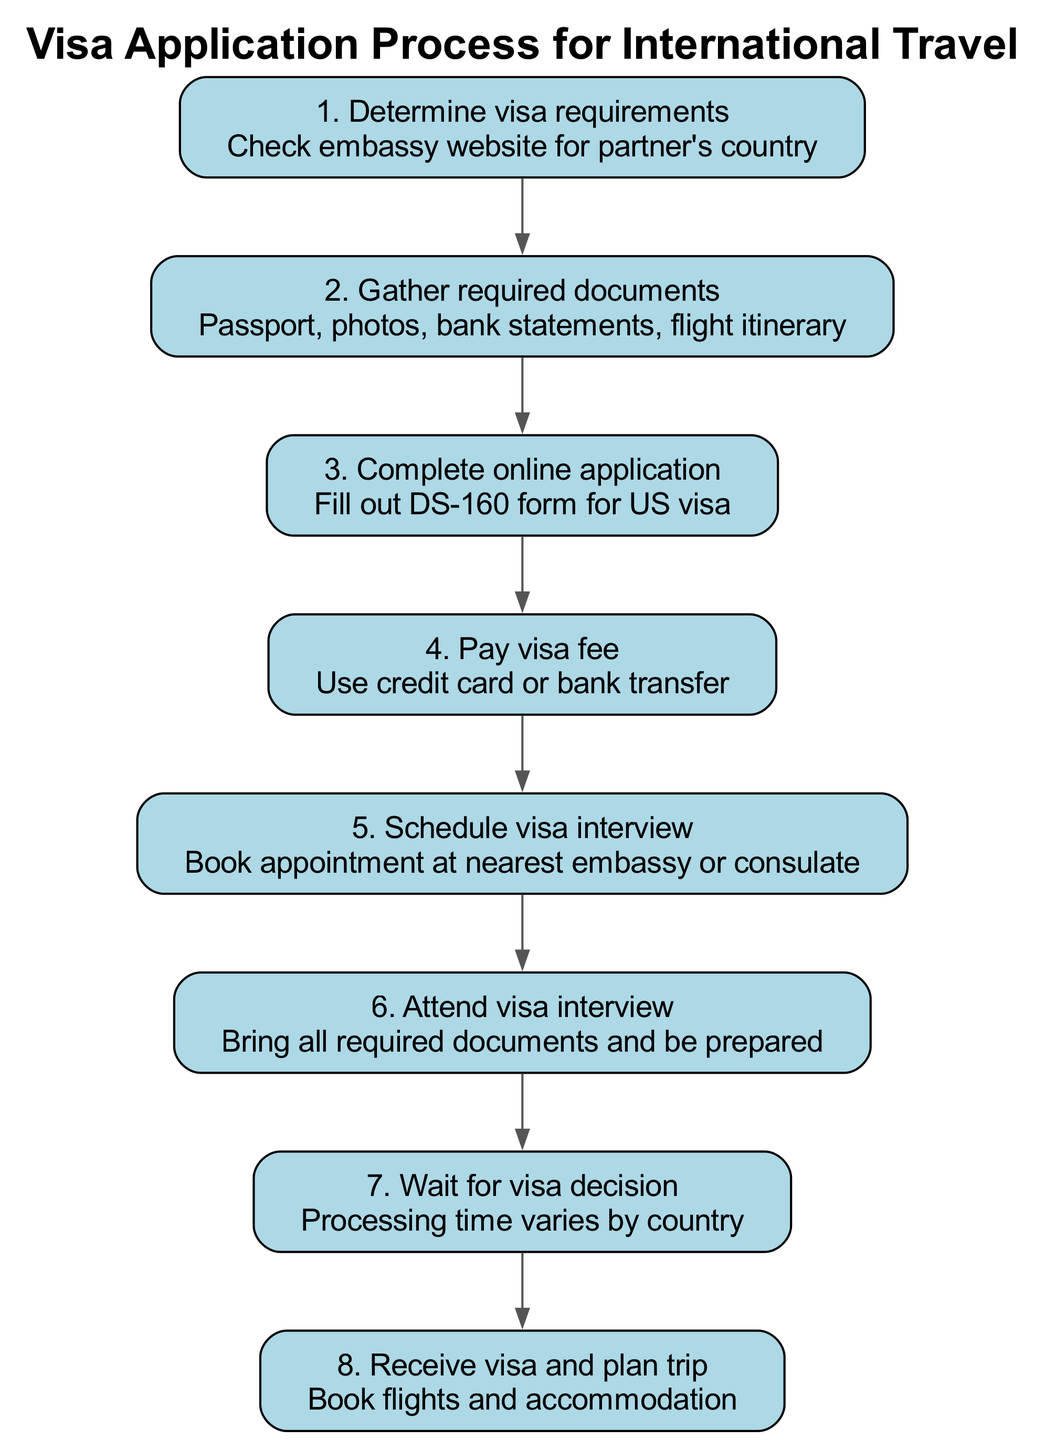What is the first step in the visa application process? The first step is to determine the visa requirements by checking the embassy website for the partner's country.
Answer: Determine visa requirements What document is required to complete the online application? The online application requires filling out the DS-160 form for a US visa, which is mentioned in the third step.
Answer: DS-160 form How many steps are there in the visa application process? The diagram indicates that there are a total of eight steps from determining visa requirements to planning the trip.
Answer: Eight What is the final action taken after receiving the visa? The final action is to receive the visa and plan the trip, which includes booking flights and accommodation.
Answer: Plan trip Which step comes immediately after paying the visa fee? After paying the visa fee, the next step is to schedule the visa interview, as indicated in the flow of the diagram.
Answer: Schedule visa interview What is the total number of connections in the diagram? There are seven connections between the steps, indicating the flow from one step to the next.
Answer: Seven What types of documents need to be gathered before applying? The required documents include a passport, photos, bank statements, and a flight itinerary, as stated in the second step.
Answer: Passport, photos, bank statements, flight itinerary What occurs after attending the visa interview? After attending the visa interview, the applicant must wait for the visa decision, as this is shown in the sequence of steps leading to the final action.
Answer: Wait for visa decision 